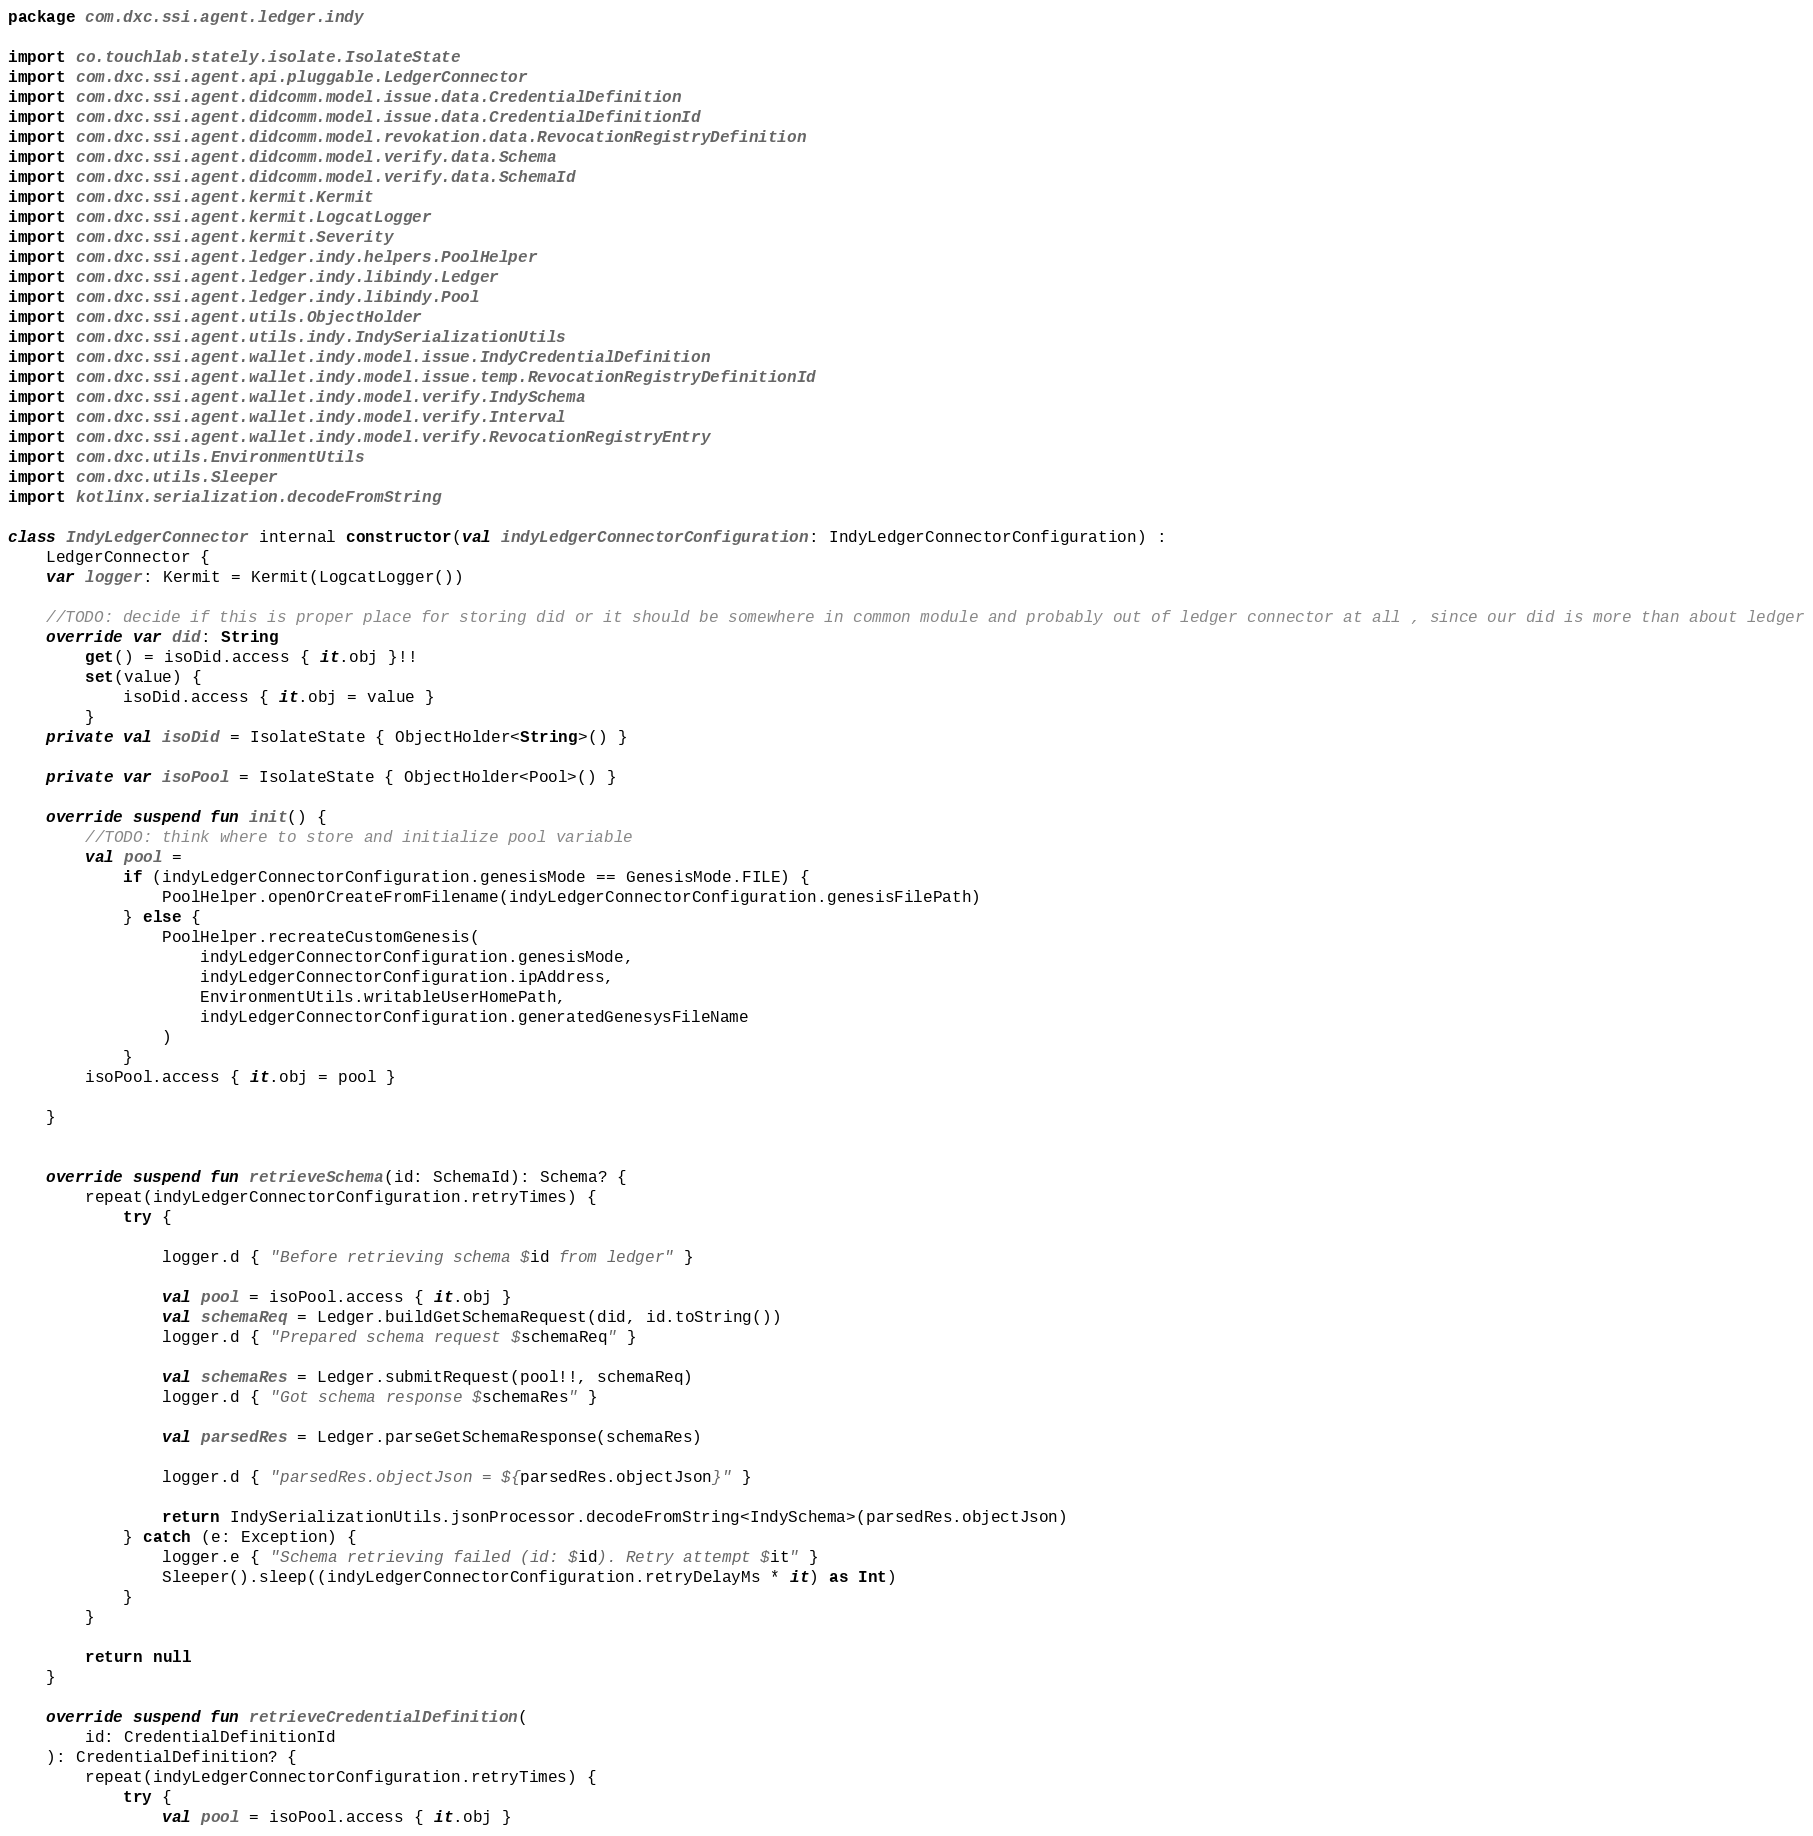<code> <loc_0><loc_0><loc_500><loc_500><_Kotlin_>package com.dxc.ssi.agent.ledger.indy

import co.touchlab.stately.isolate.IsolateState
import com.dxc.ssi.agent.api.pluggable.LedgerConnector
import com.dxc.ssi.agent.didcomm.model.issue.data.CredentialDefinition
import com.dxc.ssi.agent.didcomm.model.issue.data.CredentialDefinitionId
import com.dxc.ssi.agent.didcomm.model.revokation.data.RevocationRegistryDefinition
import com.dxc.ssi.agent.didcomm.model.verify.data.Schema
import com.dxc.ssi.agent.didcomm.model.verify.data.SchemaId
import com.dxc.ssi.agent.kermit.Kermit
import com.dxc.ssi.agent.kermit.LogcatLogger
import com.dxc.ssi.agent.kermit.Severity
import com.dxc.ssi.agent.ledger.indy.helpers.PoolHelper
import com.dxc.ssi.agent.ledger.indy.libindy.Ledger
import com.dxc.ssi.agent.ledger.indy.libindy.Pool
import com.dxc.ssi.agent.utils.ObjectHolder
import com.dxc.ssi.agent.utils.indy.IndySerializationUtils
import com.dxc.ssi.agent.wallet.indy.model.issue.IndyCredentialDefinition
import com.dxc.ssi.agent.wallet.indy.model.issue.temp.RevocationRegistryDefinitionId
import com.dxc.ssi.agent.wallet.indy.model.verify.IndySchema
import com.dxc.ssi.agent.wallet.indy.model.verify.Interval
import com.dxc.ssi.agent.wallet.indy.model.verify.RevocationRegistryEntry
import com.dxc.utils.EnvironmentUtils
import com.dxc.utils.Sleeper
import kotlinx.serialization.decodeFromString

class IndyLedgerConnector internal constructor(val indyLedgerConnectorConfiguration: IndyLedgerConnectorConfiguration) :
    LedgerConnector {
    var logger: Kermit = Kermit(LogcatLogger())

    //TODO: decide if this is proper place for storing did or it should be somewhere in common module and probably out of ledger connector at all , since our did is more than about ledger
    override var did: String
        get() = isoDid.access { it.obj }!!
        set(value) {
            isoDid.access { it.obj = value }
        }
    private val isoDid = IsolateState { ObjectHolder<String>() }

    private var isoPool = IsolateState { ObjectHolder<Pool>() }

    override suspend fun init() {
        //TODO: think where to store and initialize pool variable
        val pool =
            if (indyLedgerConnectorConfiguration.genesisMode == GenesisMode.FILE) {
                PoolHelper.openOrCreateFromFilename(indyLedgerConnectorConfiguration.genesisFilePath)
            } else {
                PoolHelper.recreateCustomGenesis(
                    indyLedgerConnectorConfiguration.genesisMode,
                    indyLedgerConnectorConfiguration.ipAddress,
                    EnvironmentUtils.writableUserHomePath,
                    indyLedgerConnectorConfiguration.generatedGenesysFileName
                )
            }
        isoPool.access { it.obj = pool }

    }


    override suspend fun retrieveSchema(id: SchemaId): Schema? {
        repeat(indyLedgerConnectorConfiguration.retryTimes) {
            try {

                logger.d { "Before retrieving schema $id from ledger" }

                val pool = isoPool.access { it.obj }
                val schemaReq = Ledger.buildGetSchemaRequest(did, id.toString())
                logger.d { "Prepared schema request $schemaReq" }

                val schemaRes = Ledger.submitRequest(pool!!, schemaReq)
                logger.d { "Got schema response $schemaRes" }

                val parsedRes = Ledger.parseGetSchemaResponse(schemaRes)

                logger.d { "parsedRes.objectJson = ${parsedRes.objectJson}" }

                return IndySerializationUtils.jsonProcessor.decodeFromString<IndySchema>(parsedRes.objectJson)
            } catch (e: Exception) {
                logger.e { "Schema retrieving failed (id: $id). Retry attempt $it" }
                Sleeper().sleep((indyLedgerConnectorConfiguration.retryDelayMs * it) as Int)
            }
        }

        return null
    }

    override suspend fun retrieveCredentialDefinition(
        id: CredentialDefinitionId
    ): CredentialDefinition? {
        repeat(indyLedgerConnectorConfiguration.retryTimes) {
            try {
                val pool = isoPool.access { it.obj }</code> 